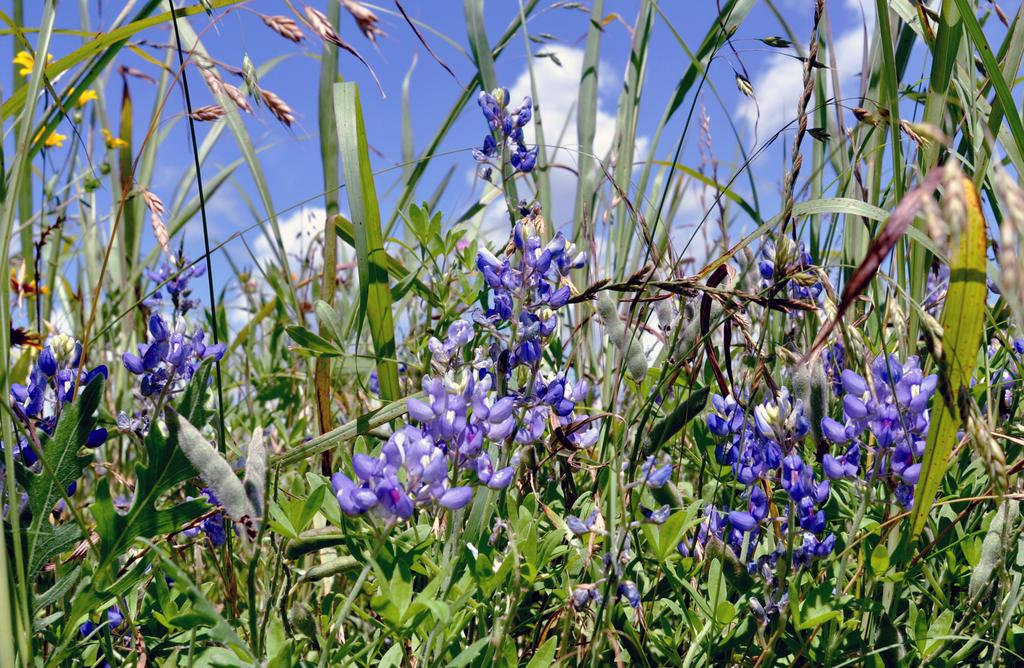What type of vegetation can be seen in the image? There are plants and flowers in the image. What is the ground covered with in the image? There is grass in the image. What can be seen in the background of the image? The sky is visible in the background of the image. What type of drum can be seen in the image? There is no drum present in the image; it features plants, flowers, and grass. How many clouds are visible in the image? There are no clouds mentioned in the provided facts, so we cannot determine the number of clouds in the image. 